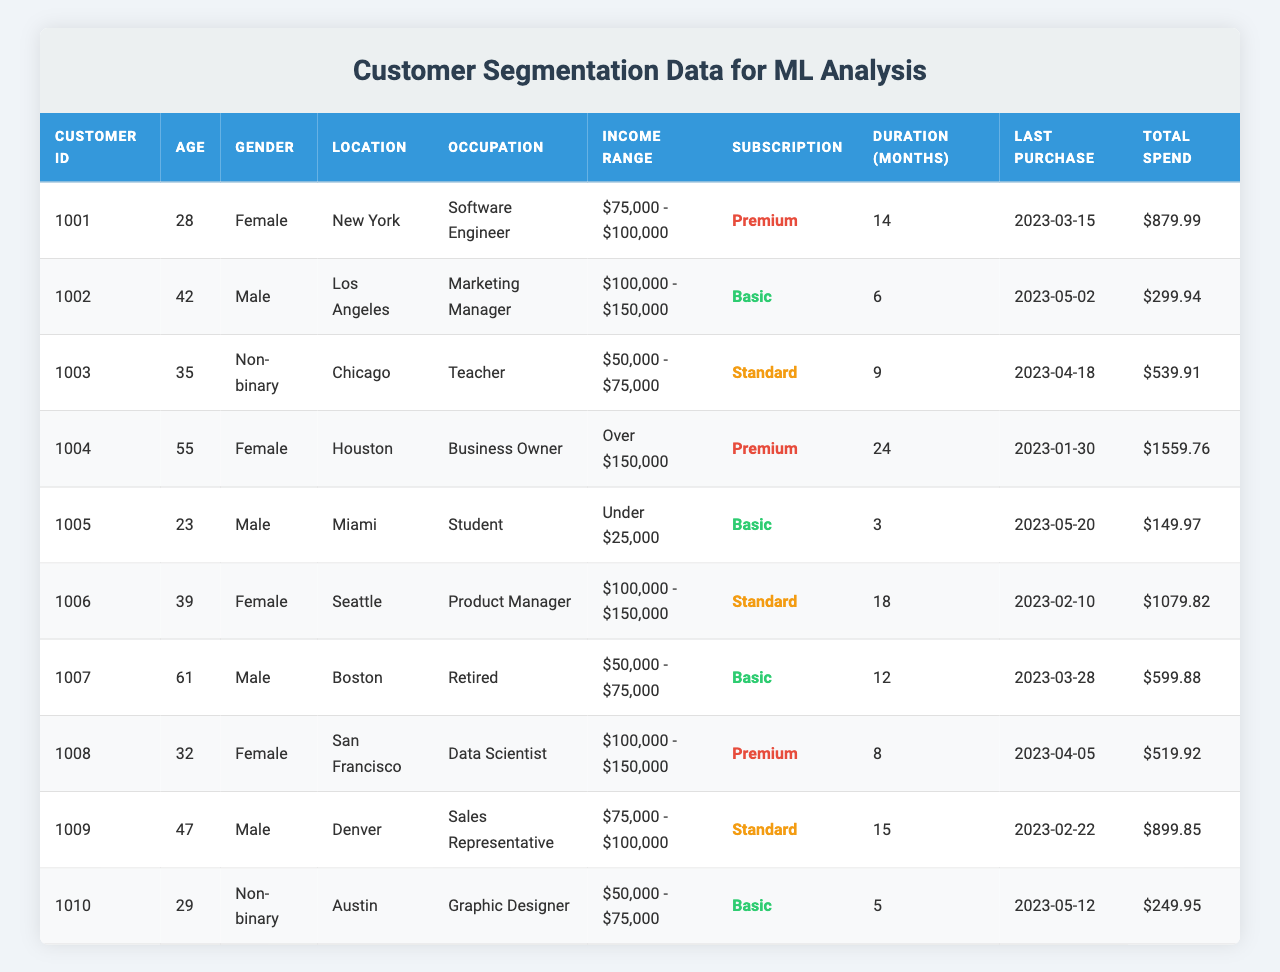What is the average age of the customers? The ages of the customers are 28, 42, 35, 55, 23, 39, 61, 32, 47, and 29. Adding these gives a total of 39. The average is calculated by dividing by the number of customers (10): (28 + 42 + 35 + 55 + 23 + 39 + 61 + 32 + 47 + 29) / 10 = 39
Answer: 39 How many customers are subscribed to the Premium plan? The table shows two customers with a subscription type labeled as Premium: customer IDs 1001 and 1004.
Answer: 2 What is the total spend of all customers in the Basic subscription? Customers in the Basic subscription are customer IDs 1002, 1005, 1007, and 1010. Their total spend values are $299.94, $149.97, $599.88, and $249.95 respectively. Adding these values gives a total of $299.94 + $149.97 + $599.88 + $249.95 = $1299.74
Answer: $1299.74 Is there a customer who is both retired and subscribed to the Standard plan? Customer ID 1007 is retired but is on the Basic plan, while no customers with a retirement occupation are on the Standard plan. Therefore, the answer is no.
Answer: No Which gender has the highest average total spend? To find this, we first separate the customers by gender. The total spends for each gender are as follows: Female: $879.99, $1559.76, $1079.82, and $519.92 for a total of $4139.49 over 4 customers (average $1034.87). For Male: $299.94, $149.97, $599.88, and $899.85 for a total of $1949.64 over 4 customers (average $487.41). Non-binary has two customers with spends $539.91 and $249.95, totalling $789.86 over 2 customers (average $394.93). Therefore, female has the highest average spend.
Answer: Female What is the income range of the oldest customer? The oldest customer is customer ID 1007, aged 61, whose income range is listed as $50,000 - $75,000.
Answer: $50,000 - $75,000 How many customers have a subscription duration of more than 12 months? The customers with more than 12 months of subscription duration are customer IDs 1004 (24 months), 1006 (18 months), and 1009 (15 months), totaling 3 customers.
Answer: 3 What percentage of customers belong to the income range "Under $25,000"? Only one customer (customer ID 1005) falls into this income range out of a total of 10 customers. The percentage is (1/10) * 100 = 10%.
Answer: 10% Is there a customer from Miami who has spent more than $500? Customer ID 1005 from Miami has spent only $149.97, which is less than $500. Hence, the answer is no.
Answer: No How many different occupations are represented in the table? The occupations listed are Software Engineer, Marketing Manager, Teacher, Business Owner, Student, Product Manager, Retired, Data Scientist, Sales Representative, and Graphic Designer. This leads to a total of 10 different occupations.
Answer: 10 What is the total number of customers from the location "Chicago"? There is 1 customer from Chicago, which is customer ID 1003.
Answer: 1 